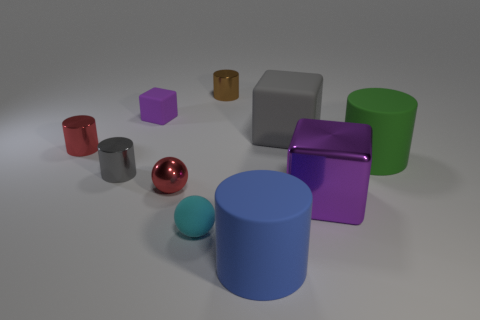The thing that is the same color as the tiny rubber block is what shape?
Make the answer very short. Cube. Do the small brown cylinder and the gray thing that is on the left side of the large gray object have the same material?
Your answer should be very brief. Yes. What number of tiny brown shiny objects are behind the purple object in front of the matte cylinder that is behind the cyan matte sphere?
Your answer should be very brief. 1. How many cyan objects are either small metal things or large rubber things?
Offer a very short reply. 0. There is a purple object that is behind the green rubber thing; what shape is it?
Offer a terse response. Cube. There is a shiny ball that is the same size as the matte sphere; what color is it?
Ensure brevity in your answer.  Red. Is the shape of the cyan object the same as the big object that is in front of the metal block?
Give a very brief answer. No. What is the material of the tiny object that is in front of the purple object that is in front of the small purple cube that is behind the small cyan rubber sphere?
Give a very brief answer. Rubber. What number of big things are either red objects or cyan shiny balls?
Offer a very short reply. 0. What number of other objects are there of the same size as the blue rubber object?
Your answer should be compact. 3. 